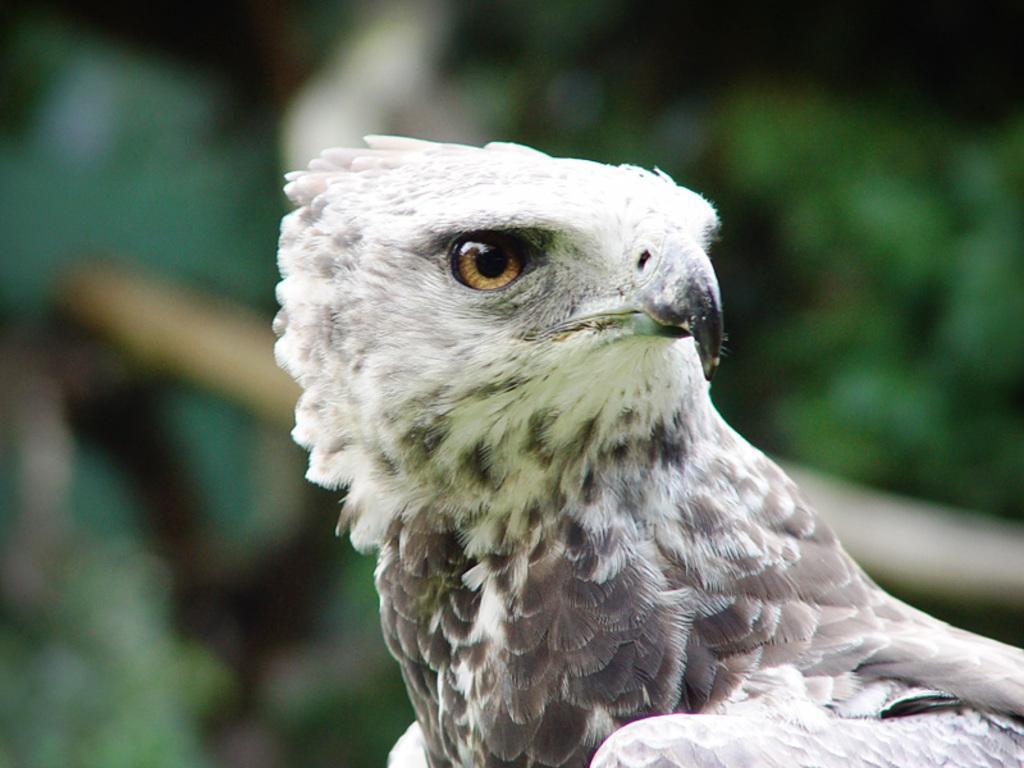In one or two sentences, can you explain what this image depicts? In this picture we can see a bird. In the background of the image it is blurry. 